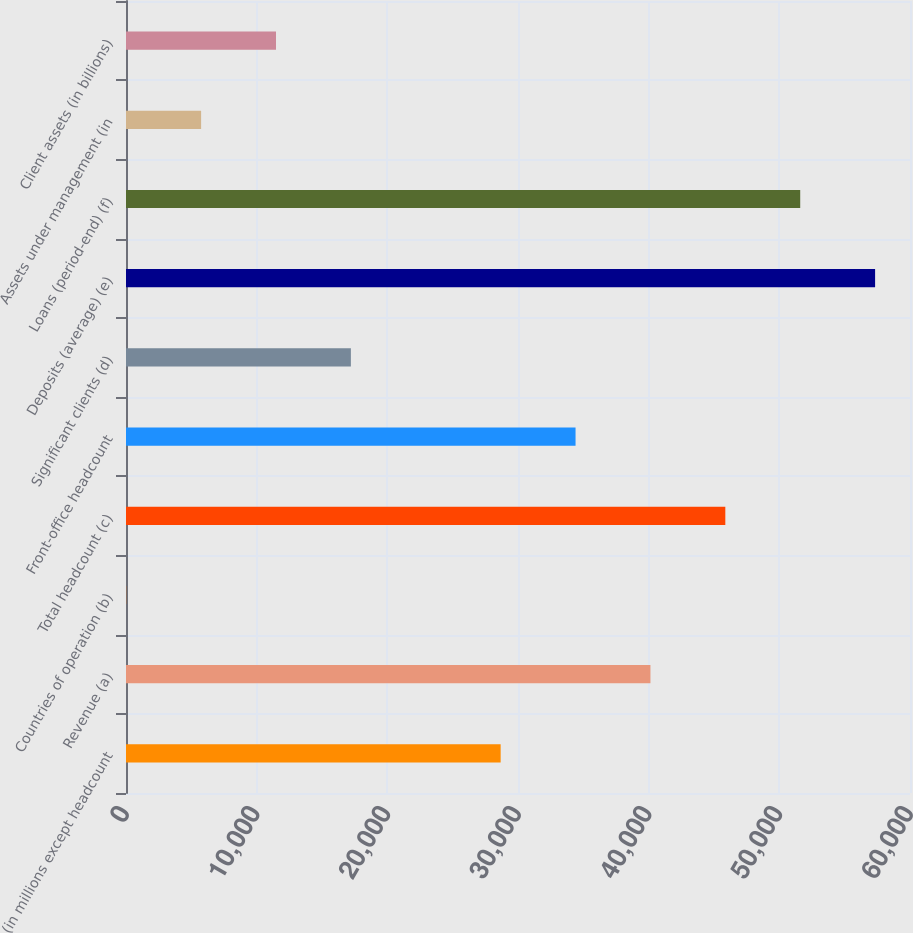<chart> <loc_0><loc_0><loc_500><loc_500><bar_chart><fcel>(in millions except headcount<fcel>Revenue (a)<fcel>Countries of operation (b)<fcel>Total headcount (c)<fcel>Front-office headcount<fcel>Significant clients (d)<fcel>Deposits (average) (e)<fcel>Loans (period-end) (f)<fcel>Assets under management (in<fcel>Client assets (in billions)<nl><fcel>28673<fcel>40135.4<fcel>17<fcel>45866.6<fcel>34404.2<fcel>17210.6<fcel>57329<fcel>51597.8<fcel>5748.2<fcel>11479.4<nl></chart> 